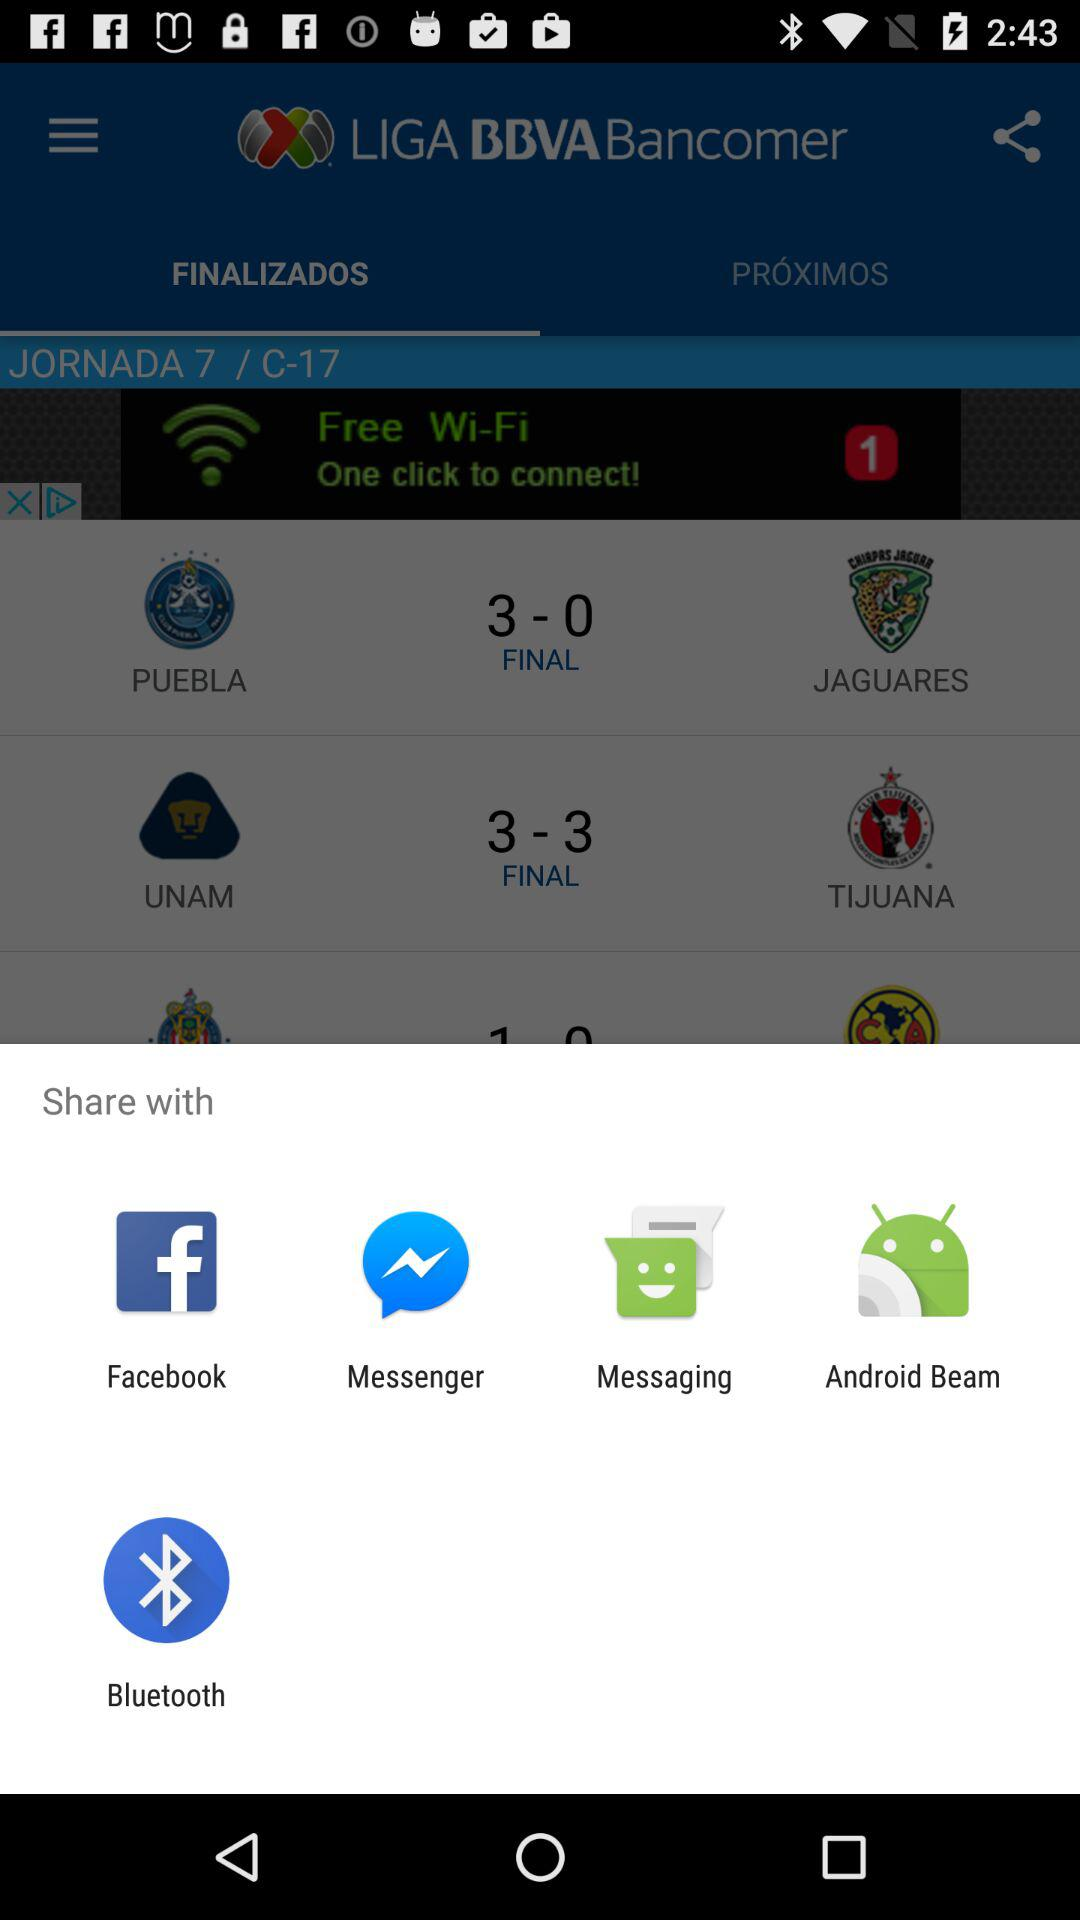When will "PUEBLA" play next?
When the provided information is insufficient, respond with <no answer>. <no answer> 